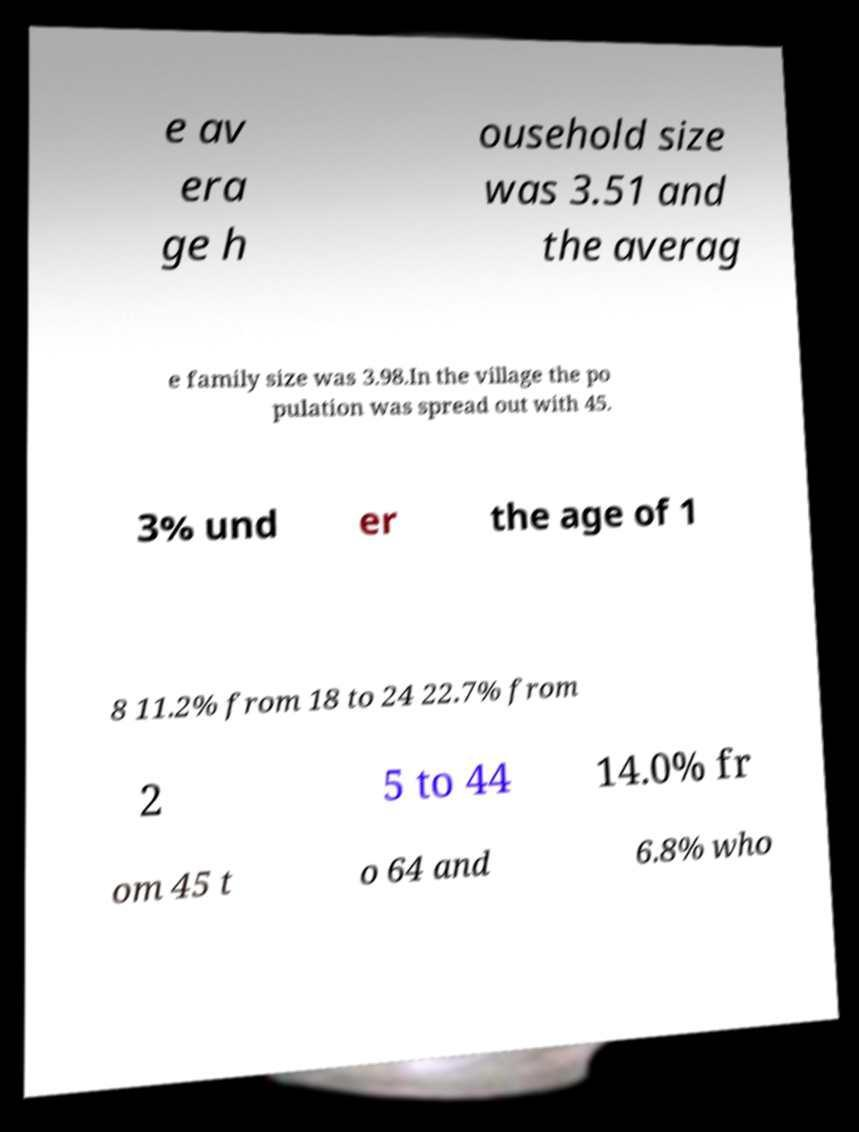Can you accurately transcribe the text from the provided image for me? e av era ge h ousehold size was 3.51 and the averag e family size was 3.98.In the village the po pulation was spread out with 45. 3% und er the age of 1 8 11.2% from 18 to 24 22.7% from 2 5 to 44 14.0% fr om 45 t o 64 and 6.8% who 